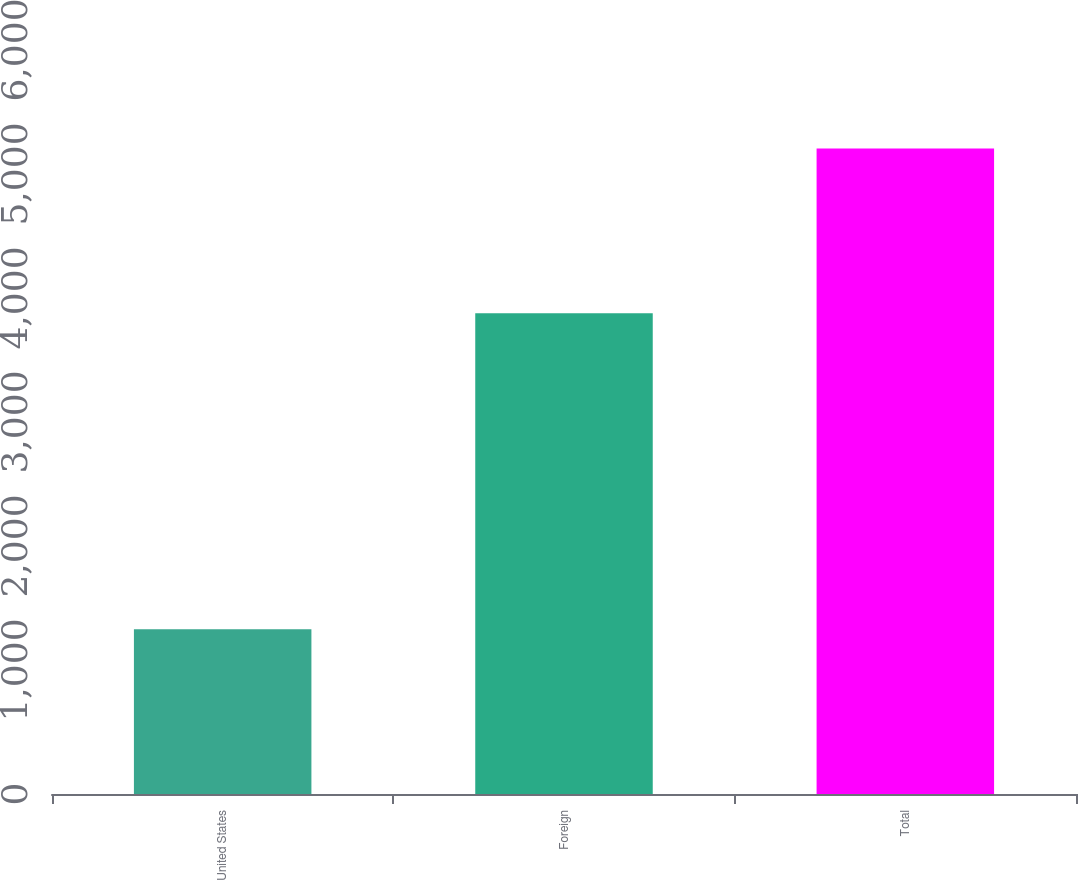Convert chart to OTSL. <chart><loc_0><loc_0><loc_500><loc_500><bar_chart><fcel>United States<fcel>Foreign<fcel>Total<nl><fcel>1328<fcel>3878<fcel>5206<nl></chart> 